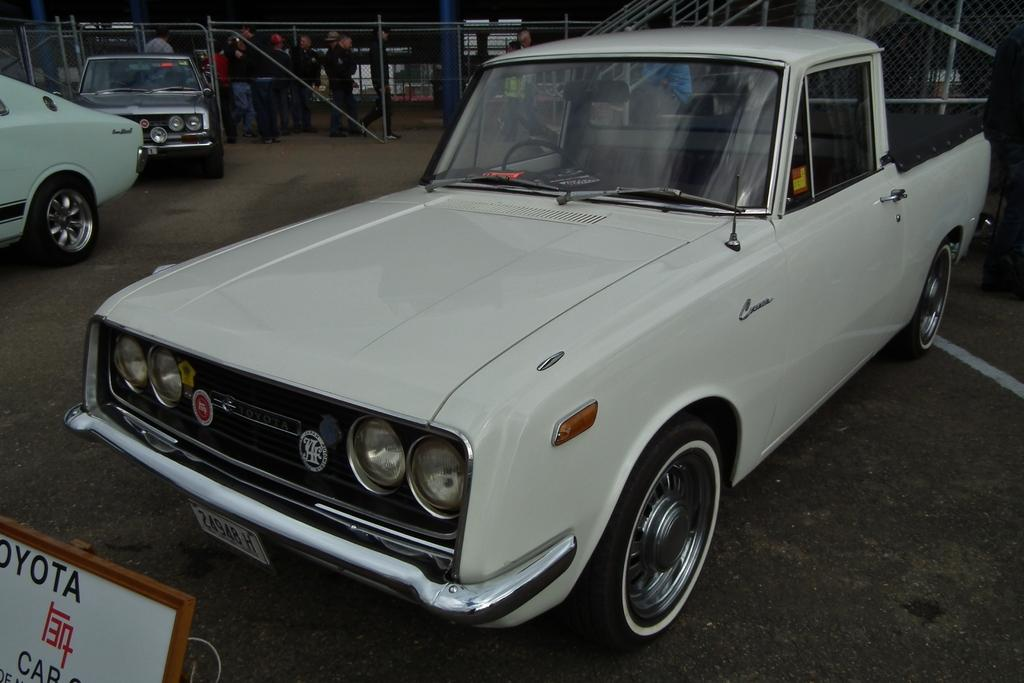What can be seen in the image related to transportation? There are vehicles in the image. What is the purpose of the name board in the image? The name board in the image is likely used for identification or direction. Can you describe the people in the image? There are group of people standing in the image. What type of material is used for the fencing in the image? There are iron rods in the image, which are part of the wire fence. How many buns are being held by the people in the image? There is no mention of buns in the image; the focus is on vehicles, a name board, a group of people, iron rods, and a wire fence. 